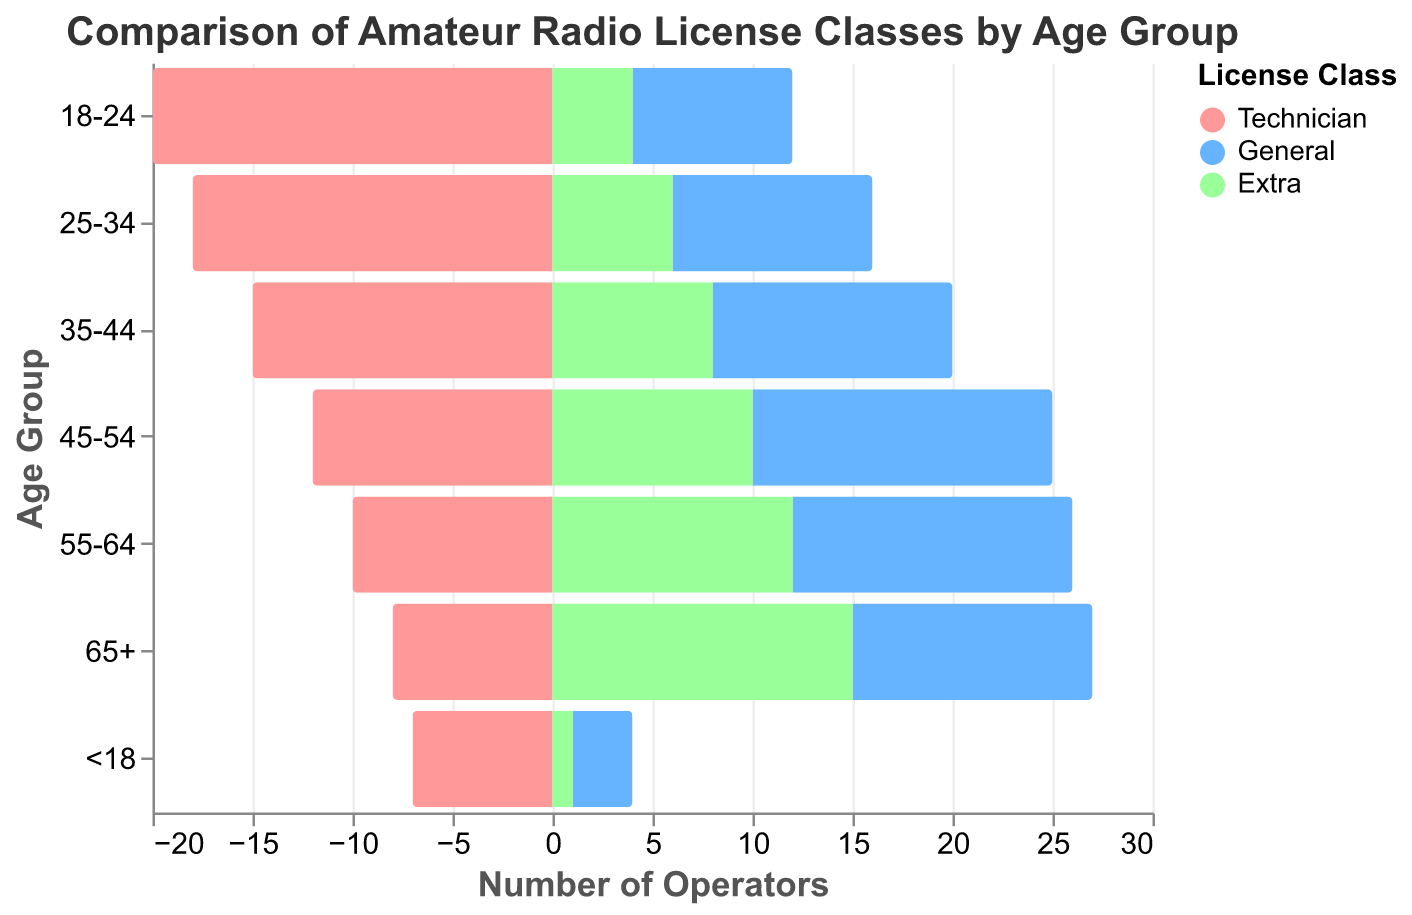What's the title of the figure? The title is located at the top of the figure and indicates what the chart is about.
Answer: Comparison of Amateur Radio License Classes by Age Group Which age group has the highest number of Technician license holders? By analyzing the bar lengths in the Technician category, the longest bar indicates the highest number.
Answer: 18-24 In the 45-54 age group, which license class has the least number of holders? Within the 45-54 age group, examine the bars for Technician, General, and Extra classes to find the shortest one.
Answer: Extra How many total radio operators are there in the 55-64 age group across all license classes? Sum the number of operators in each license class for the 55-64 age group: Technician (10) + General (14) + Extra (12).
Answer: 36 Is the number of Extra license holders greater than the number of General license holders in the 65+ age group? Compare the values for Extra (15) and General (12) in the 65+ age group to determine which is larger.
Answer: Yes Among the age groups <18, which category has the smallest number of license holders? Check the bars for Technician, General, and Extra in the <18 age group to identify the shortest one.
Answer: Extra What is the average number of Extra license holders in the age groups 25-34 and 35-44? Calculate the average by summing the counts of Extra license holders in 25-34 (6) and 35-44 (8), then divide by 2.
Answer: 7 Compare the number of Technician and Extra license holders in the 18-24 age group. Which is higher and by how much? The Technician count is 20 and Extra is 4 in the 18-24 age group. Subtract the Extra count from the Technician count.
Answer: Technician, by 16 Across all age groups, how many individuals hold a General license in total? Sum the General license numbers for all age groups: 12 + 14 + 15 + 12 + 10 + 8 + 3.
Answer: 74 What trend do you observe for Technician license holders from the age group 18-24 to 65+? Examine the Technician bars from 18-24 to 65+, noting whether they increase or decrease.
Answer: Decreasing trend 